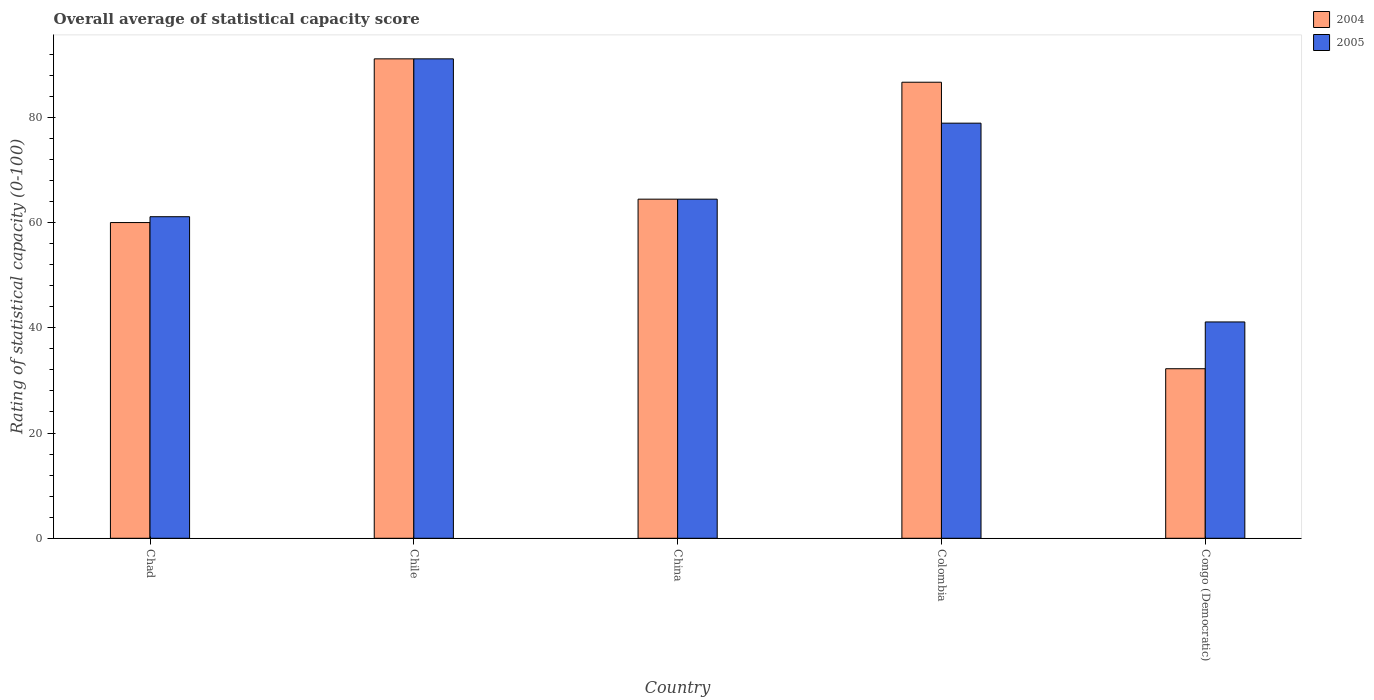How many different coloured bars are there?
Your answer should be very brief. 2. How many groups of bars are there?
Keep it short and to the point. 5. Are the number of bars per tick equal to the number of legend labels?
Your answer should be very brief. Yes. What is the label of the 4th group of bars from the left?
Make the answer very short. Colombia. In how many cases, is the number of bars for a given country not equal to the number of legend labels?
Offer a very short reply. 0. What is the rating of statistical capacity in 2004 in China?
Provide a succinct answer. 64.44. Across all countries, what is the maximum rating of statistical capacity in 2004?
Your answer should be very brief. 91.11. Across all countries, what is the minimum rating of statistical capacity in 2005?
Provide a short and direct response. 41.11. In which country was the rating of statistical capacity in 2005 minimum?
Your answer should be compact. Congo (Democratic). What is the total rating of statistical capacity in 2005 in the graph?
Ensure brevity in your answer.  336.67. What is the difference between the rating of statistical capacity in 2005 in Colombia and that in Congo (Democratic)?
Provide a short and direct response. 37.78. What is the difference between the rating of statistical capacity in 2004 in China and the rating of statistical capacity in 2005 in Colombia?
Give a very brief answer. -14.44. What is the average rating of statistical capacity in 2005 per country?
Offer a terse response. 67.33. What is the difference between the rating of statistical capacity of/in 2005 and rating of statistical capacity of/in 2004 in Colombia?
Make the answer very short. -7.78. In how many countries, is the rating of statistical capacity in 2004 greater than 76?
Offer a very short reply. 2. What is the ratio of the rating of statistical capacity in 2005 in Colombia to that in Congo (Democratic)?
Ensure brevity in your answer.  1.92. What is the difference between the highest and the second highest rating of statistical capacity in 2005?
Offer a very short reply. -26.67. What is the difference between the highest and the lowest rating of statistical capacity in 2005?
Offer a very short reply. 50. How many bars are there?
Make the answer very short. 10. Are all the bars in the graph horizontal?
Your response must be concise. No. How many countries are there in the graph?
Your response must be concise. 5. Are the values on the major ticks of Y-axis written in scientific E-notation?
Provide a short and direct response. No. How many legend labels are there?
Your answer should be compact. 2. What is the title of the graph?
Offer a terse response. Overall average of statistical capacity score. What is the label or title of the X-axis?
Provide a succinct answer. Country. What is the label or title of the Y-axis?
Your answer should be compact. Rating of statistical capacity (0-100). What is the Rating of statistical capacity (0-100) of 2004 in Chad?
Your response must be concise. 60. What is the Rating of statistical capacity (0-100) of 2005 in Chad?
Give a very brief answer. 61.11. What is the Rating of statistical capacity (0-100) of 2004 in Chile?
Give a very brief answer. 91.11. What is the Rating of statistical capacity (0-100) of 2005 in Chile?
Your response must be concise. 91.11. What is the Rating of statistical capacity (0-100) of 2004 in China?
Provide a succinct answer. 64.44. What is the Rating of statistical capacity (0-100) of 2005 in China?
Ensure brevity in your answer.  64.44. What is the Rating of statistical capacity (0-100) of 2004 in Colombia?
Ensure brevity in your answer.  86.67. What is the Rating of statistical capacity (0-100) of 2005 in Colombia?
Your response must be concise. 78.89. What is the Rating of statistical capacity (0-100) of 2004 in Congo (Democratic)?
Provide a short and direct response. 32.22. What is the Rating of statistical capacity (0-100) of 2005 in Congo (Democratic)?
Ensure brevity in your answer.  41.11. Across all countries, what is the maximum Rating of statistical capacity (0-100) in 2004?
Make the answer very short. 91.11. Across all countries, what is the maximum Rating of statistical capacity (0-100) of 2005?
Provide a short and direct response. 91.11. Across all countries, what is the minimum Rating of statistical capacity (0-100) in 2004?
Ensure brevity in your answer.  32.22. Across all countries, what is the minimum Rating of statistical capacity (0-100) of 2005?
Offer a very short reply. 41.11. What is the total Rating of statistical capacity (0-100) in 2004 in the graph?
Offer a terse response. 334.44. What is the total Rating of statistical capacity (0-100) in 2005 in the graph?
Keep it short and to the point. 336.67. What is the difference between the Rating of statistical capacity (0-100) of 2004 in Chad and that in Chile?
Keep it short and to the point. -31.11. What is the difference between the Rating of statistical capacity (0-100) of 2004 in Chad and that in China?
Your response must be concise. -4.44. What is the difference between the Rating of statistical capacity (0-100) of 2004 in Chad and that in Colombia?
Make the answer very short. -26.67. What is the difference between the Rating of statistical capacity (0-100) of 2005 in Chad and that in Colombia?
Your answer should be very brief. -17.78. What is the difference between the Rating of statistical capacity (0-100) in 2004 in Chad and that in Congo (Democratic)?
Your answer should be compact. 27.78. What is the difference between the Rating of statistical capacity (0-100) of 2005 in Chad and that in Congo (Democratic)?
Ensure brevity in your answer.  20. What is the difference between the Rating of statistical capacity (0-100) in 2004 in Chile and that in China?
Offer a very short reply. 26.67. What is the difference between the Rating of statistical capacity (0-100) in 2005 in Chile and that in China?
Ensure brevity in your answer.  26.67. What is the difference between the Rating of statistical capacity (0-100) of 2004 in Chile and that in Colombia?
Your answer should be very brief. 4.44. What is the difference between the Rating of statistical capacity (0-100) of 2005 in Chile and that in Colombia?
Provide a short and direct response. 12.22. What is the difference between the Rating of statistical capacity (0-100) in 2004 in Chile and that in Congo (Democratic)?
Provide a succinct answer. 58.89. What is the difference between the Rating of statistical capacity (0-100) of 2004 in China and that in Colombia?
Ensure brevity in your answer.  -22.22. What is the difference between the Rating of statistical capacity (0-100) of 2005 in China and that in Colombia?
Your answer should be very brief. -14.44. What is the difference between the Rating of statistical capacity (0-100) of 2004 in China and that in Congo (Democratic)?
Your response must be concise. 32.22. What is the difference between the Rating of statistical capacity (0-100) in 2005 in China and that in Congo (Democratic)?
Give a very brief answer. 23.33. What is the difference between the Rating of statistical capacity (0-100) in 2004 in Colombia and that in Congo (Democratic)?
Keep it short and to the point. 54.44. What is the difference between the Rating of statistical capacity (0-100) in 2005 in Colombia and that in Congo (Democratic)?
Ensure brevity in your answer.  37.78. What is the difference between the Rating of statistical capacity (0-100) in 2004 in Chad and the Rating of statistical capacity (0-100) in 2005 in Chile?
Give a very brief answer. -31.11. What is the difference between the Rating of statistical capacity (0-100) in 2004 in Chad and the Rating of statistical capacity (0-100) in 2005 in China?
Keep it short and to the point. -4.44. What is the difference between the Rating of statistical capacity (0-100) in 2004 in Chad and the Rating of statistical capacity (0-100) in 2005 in Colombia?
Provide a short and direct response. -18.89. What is the difference between the Rating of statistical capacity (0-100) of 2004 in Chad and the Rating of statistical capacity (0-100) of 2005 in Congo (Democratic)?
Your response must be concise. 18.89. What is the difference between the Rating of statistical capacity (0-100) of 2004 in Chile and the Rating of statistical capacity (0-100) of 2005 in China?
Your response must be concise. 26.67. What is the difference between the Rating of statistical capacity (0-100) of 2004 in Chile and the Rating of statistical capacity (0-100) of 2005 in Colombia?
Your answer should be very brief. 12.22. What is the difference between the Rating of statistical capacity (0-100) in 2004 in Chile and the Rating of statistical capacity (0-100) in 2005 in Congo (Democratic)?
Keep it short and to the point. 50. What is the difference between the Rating of statistical capacity (0-100) of 2004 in China and the Rating of statistical capacity (0-100) of 2005 in Colombia?
Your response must be concise. -14.44. What is the difference between the Rating of statistical capacity (0-100) in 2004 in China and the Rating of statistical capacity (0-100) in 2005 in Congo (Democratic)?
Offer a very short reply. 23.33. What is the difference between the Rating of statistical capacity (0-100) in 2004 in Colombia and the Rating of statistical capacity (0-100) in 2005 in Congo (Democratic)?
Give a very brief answer. 45.56. What is the average Rating of statistical capacity (0-100) of 2004 per country?
Provide a succinct answer. 66.89. What is the average Rating of statistical capacity (0-100) in 2005 per country?
Offer a very short reply. 67.33. What is the difference between the Rating of statistical capacity (0-100) of 2004 and Rating of statistical capacity (0-100) of 2005 in Chad?
Provide a succinct answer. -1.11. What is the difference between the Rating of statistical capacity (0-100) of 2004 and Rating of statistical capacity (0-100) of 2005 in Chile?
Your response must be concise. 0. What is the difference between the Rating of statistical capacity (0-100) in 2004 and Rating of statistical capacity (0-100) in 2005 in Colombia?
Your answer should be very brief. 7.78. What is the difference between the Rating of statistical capacity (0-100) of 2004 and Rating of statistical capacity (0-100) of 2005 in Congo (Democratic)?
Your response must be concise. -8.89. What is the ratio of the Rating of statistical capacity (0-100) of 2004 in Chad to that in Chile?
Your answer should be very brief. 0.66. What is the ratio of the Rating of statistical capacity (0-100) of 2005 in Chad to that in Chile?
Offer a terse response. 0.67. What is the ratio of the Rating of statistical capacity (0-100) in 2005 in Chad to that in China?
Provide a short and direct response. 0.95. What is the ratio of the Rating of statistical capacity (0-100) in 2004 in Chad to that in Colombia?
Keep it short and to the point. 0.69. What is the ratio of the Rating of statistical capacity (0-100) of 2005 in Chad to that in Colombia?
Give a very brief answer. 0.77. What is the ratio of the Rating of statistical capacity (0-100) of 2004 in Chad to that in Congo (Democratic)?
Keep it short and to the point. 1.86. What is the ratio of the Rating of statistical capacity (0-100) in 2005 in Chad to that in Congo (Democratic)?
Ensure brevity in your answer.  1.49. What is the ratio of the Rating of statistical capacity (0-100) of 2004 in Chile to that in China?
Give a very brief answer. 1.41. What is the ratio of the Rating of statistical capacity (0-100) of 2005 in Chile to that in China?
Provide a short and direct response. 1.41. What is the ratio of the Rating of statistical capacity (0-100) of 2004 in Chile to that in Colombia?
Keep it short and to the point. 1.05. What is the ratio of the Rating of statistical capacity (0-100) of 2005 in Chile to that in Colombia?
Your response must be concise. 1.15. What is the ratio of the Rating of statistical capacity (0-100) of 2004 in Chile to that in Congo (Democratic)?
Your answer should be compact. 2.83. What is the ratio of the Rating of statistical capacity (0-100) of 2005 in Chile to that in Congo (Democratic)?
Your response must be concise. 2.22. What is the ratio of the Rating of statistical capacity (0-100) of 2004 in China to that in Colombia?
Provide a succinct answer. 0.74. What is the ratio of the Rating of statistical capacity (0-100) of 2005 in China to that in Colombia?
Your answer should be compact. 0.82. What is the ratio of the Rating of statistical capacity (0-100) in 2004 in China to that in Congo (Democratic)?
Provide a succinct answer. 2. What is the ratio of the Rating of statistical capacity (0-100) of 2005 in China to that in Congo (Democratic)?
Your answer should be very brief. 1.57. What is the ratio of the Rating of statistical capacity (0-100) in 2004 in Colombia to that in Congo (Democratic)?
Give a very brief answer. 2.69. What is the ratio of the Rating of statistical capacity (0-100) in 2005 in Colombia to that in Congo (Democratic)?
Keep it short and to the point. 1.92. What is the difference between the highest and the second highest Rating of statistical capacity (0-100) of 2004?
Offer a very short reply. 4.44. What is the difference between the highest and the second highest Rating of statistical capacity (0-100) in 2005?
Your answer should be very brief. 12.22. What is the difference between the highest and the lowest Rating of statistical capacity (0-100) of 2004?
Your answer should be compact. 58.89. 